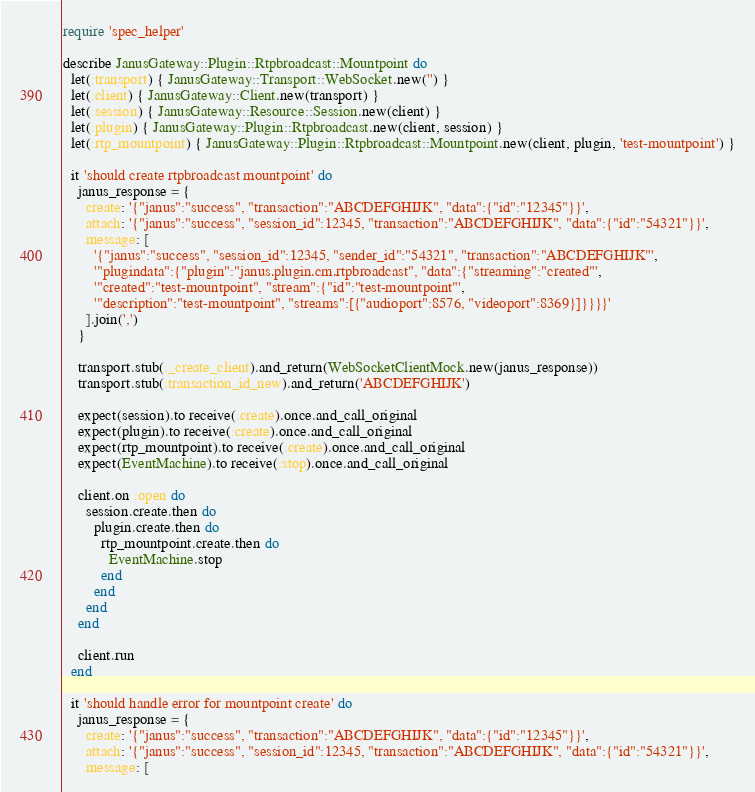Convert code to text. <code><loc_0><loc_0><loc_500><loc_500><_Ruby_>require 'spec_helper'

describe JanusGateway::Plugin::Rtpbroadcast::Mountpoint do
  let(:transport) { JanusGateway::Transport::WebSocket.new('') }
  let(:client) { JanusGateway::Client.new(transport) }
  let(:session) { JanusGateway::Resource::Session.new(client) }
  let(:plugin) { JanusGateway::Plugin::Rtpbroadcast.new(client, session) }
  let(:rtp_mountpoint) { JanusGateway::Plugin::Rtpbroadcast::Mountpoint.new(client, plugin, 'test-mountpoint') }

  it 'should create rtpbroadcast mountpoint' do
    janus_response = {
      create: '{"janus":"success", "transaction":"ABCDEFGHIJK", "data":{"id":"12345"}}',
      attach: '{"janus":"success", "session_id":12345, "transaction":"ABCDEFGHIJK", "data":{"id":"54321"}}',
      message: [
        '{"janus":"success", "session_id":12345, "sender_id":"54321", "transaction":"ABCDEFGHIJK"',
        '"plugindata":{"plugin":"janus.plugin.cm.rtpbroadcast", "data":{"streaming":"created"',
        '"created":"test-mountpoint", "stream":{"id":"test-mountpoint"',
        '"description":"test-mountpoint", "streams":[{"audioport":8576, "videoport":8369}]}}}}'
      ].join(',')
    }

    transport.stub(:_create_client).and_return(WebSocketClientMock.new(janus_response))
    transport.stub(:transaction_id_new).and_return('ABCDEFGHIJK')

    expect(session).to receive(:create).once.and_call_original
    expect(plugin).to receive(:create).once.and_call_original
    expect(rtp_mountpoint).to receive(:create).once.and_call_original
    expect(EventMachine).to receive(:stop).once.and_call_original

    client.on :open do
      session.create.then do
        plugin.create.then do
          rtp_mountpoint.create.then do
            EventMachine.stop
          end
        end
      end
    end

    client.run
  end

  it 'should handle error for mountpoint create' do
    janus_response = {
      create: '{"janus":"success", "transaction":"ABCDEFGHIJK", "data":{"id":"12345"}}',
      attach: '{"janus":"success", "session_id":12345, "transaction":"ABCDEFGHIJK", "data":{"id":"54321"}}',
      message: [</code> 